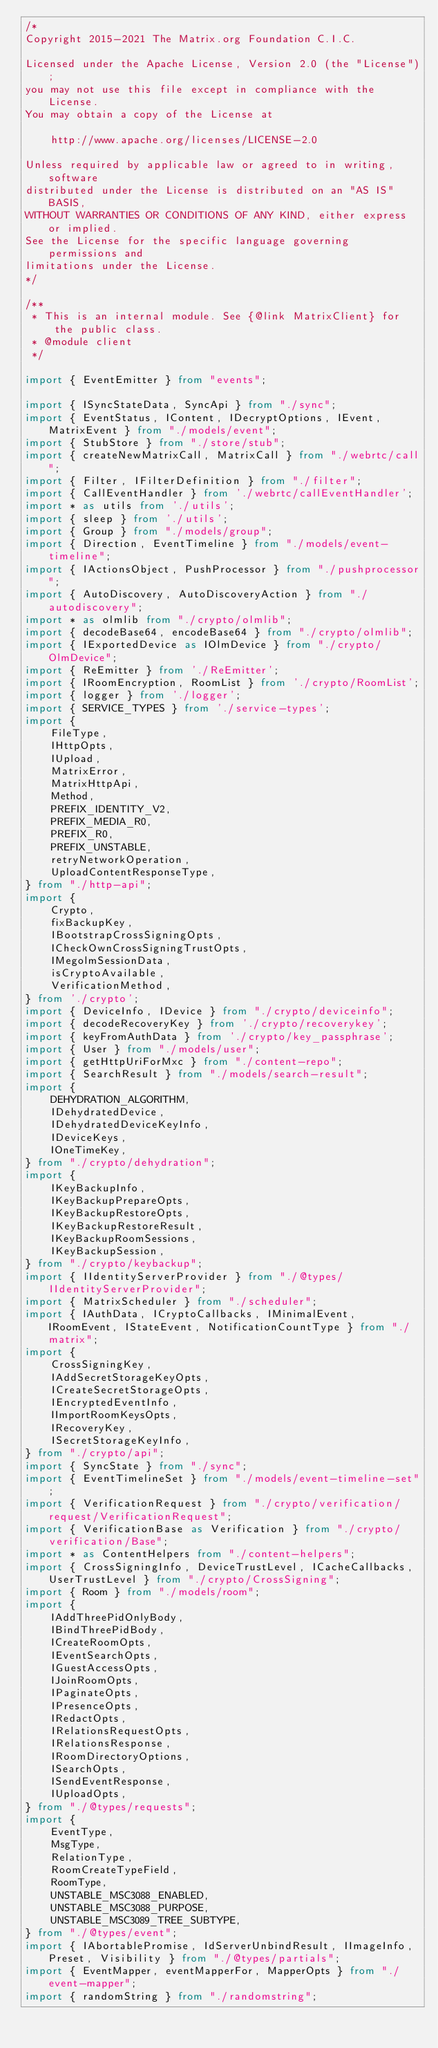<code> <loc_0><loc_0><loc_500><loc_500><_TypeScript_>/*
Copyright 2015-2021 The Matrix.org Foundation C.I.C.

Licensed under the Apache License, Version 2.0 (the "License");
you may not use this file except in compliance with the License.
You may obtain a copy of the License at

    http://www.apache.org/licenses/LICENSE-2.0

Unless required by applicable law or agreed to in writing, software
distributed under the License is distributed on an "AS IS" BASIS,
WITHOUT WARRANTIES OR CONDITIONS OF ANY KIND, either express or implied.
See the License for the specific language governing permissions and
limitations under the License.
*/

/**
 * This is an internal module. See {@link MatrixClient} for the public class.
 * @module client
 */

import { EventEmitter } from "events";

import { ISyncStateData, SyncApi } from "./sync";
import { EventStatus, IContent, IDecryptOptions, IEvent, MatrixEvent } from "./models/event";
import { StubStore } from "./store/stub";
import { createNewMatrixCall, MatrixCall } from "./webrtc/call";
import { Filter, IFilterDefinition } from "./filter";
import { CallEventHandler } from './webrtc/callEventHandler';
import * as utils from './utils';
import { sleep } from './utils';
import { Group } from "./models/group";
import { Direction, EventTimeline } from "./models/event-timeline";
import { IActionsObject, PushProcessor } from "./pushprocessor";
import { AutoDiscovery, AutoDiscoveryAction } from "./autodiscovery";
import * as olmlib from "./crypto/olmlib";
import { decodeBase64, encodeBase64 } from "./crypto/olmlib";
import { IExportedDevice as IOlmDevice } from "./crypto/OlmDevice";
import { ReEmitter } from './ReEmitter';
import { IRoomEncryption, RoomList } from './crypto/RoomList';
import { logger } from './logger';
import { SERVICE_TYPES } from './service-types';
import {
    FileType,
    IHttpOpts,
    IUpload,
    MatrixError,
    MatrixHttpApi,
    Method,
    PREFIX_IDENTITY_V2,
    PREFIX_MEDIA_R0,
    PREFIX_R0,
    PREFIX_UNSTABLE,
    retryNetworkOperation,
    UploadContentResponseType,
} from "./http-api";
import {
    Crypto,
    fixBackupKey,
    IBootstrapCrossSigningOpts,
    ICheckOwnCrossSigningTrustOpts,
    IMegolmSessionData,
    isCryptoAvailable,
    VerificationMethod,
} from './crypto';
import { DeviceInfo, IDevice } from "./crypto/deviceinfo";
import { decodeRecoveryKey } from './crypto/recoverykey';
import { keyFromAuthData } from './crypto/key_passphrase';
import { User } from "./models/user";
import { getHttpUriForMxc } from "./content-repo";
import { SearchResult } from "./models/search-result";
import {
    DEHYDRATION_ALGORITHM,
    IDehydratedDevice,
    IDehydratedDeviceKeyInfo,
    IDeviceKeys,
    IOneTimeKey,
} from "./crypto/dehydration";
import {
    IKeyBackupInfo,
    IKeyBackupPrepareOpts,
    IKeyBackupRestoreOpts,
    IKeyBackupRestoreResult,
    IKeyBackupRoomSessions,
    IKeyBackupSession,
} from "./crypto/keybackup";
import { IIdentityServerProvider } from "./@types/IIdentityServerProvider";
import { MatrixScheduler } from "./scheduler";
import { IAuthData, ICryptoCallbacks, IMinimalEvent, IRoomEvent, IStateEvent, NotificationCountType } from "./matrix";
import {
    CrossSigningKey,
    IAddSecretStorageKeyOpts,
    ICreateSecretStorageOpts,
    IEncryptedEventInfo,
    IImportRoomKeysOpts,
    IRecoveryKey,
    ISecretStorageKeyInfo,
} from "./crypto/api";
import { SyncState } from "./sync";
import { EventTimelineSet } from "./models/event-timeline-set";
import { VerificationRequest } from "./crypto/verification/request/VerificationRequest";
import { VerificationBase as Verification } from "./crypto/verification/Base";
import * as ContentHelpers from "./content-helpers";
import { CrossSigningInfo, DeviceTrustLevel, ICacheCallbacks, UserTrustLevel } from "./crypto/CrossSigning";
import { Room } from "./models/room";
import {
    IAddThreePidOnlyBody,
    IBindThreePidBody,
    ICreateRoomOpts,
    IEventSearchOpts,
    IGuestAccessOpts,
    IJoinRoomOpts,
    IPaginateOpts,
    IPresenceOpts,
    IRedactOpts,
    IRelationsRequestOpts,
    IRelationsResponse,
    IRoomDirectoryOptions,
    ISearchOpts,
    ISendEventResponse,
    IUploadOpts,
} from "./@types/requests";
import {
    EventType,
    MsgType,
    RelationType,
    RoomCreateTypeField,
    RoomType,
    UNSTABLE_MSC3088_ENABLED,
    UNSTABLE_MSC3088_PURPOSE,
    UNSTABLE_MSC3089_TREE_SUBTYPE,
} from "./@types/event";
import { IAbortablePromise, IdServerUnbindResult, IImageInfo, Preset, Visibility } from "./@types/partials";
import { EventMapper, eventMapperFor, MapperOpts } from "./event-mapper";
import { randomString } from "./randomstring";</code> 